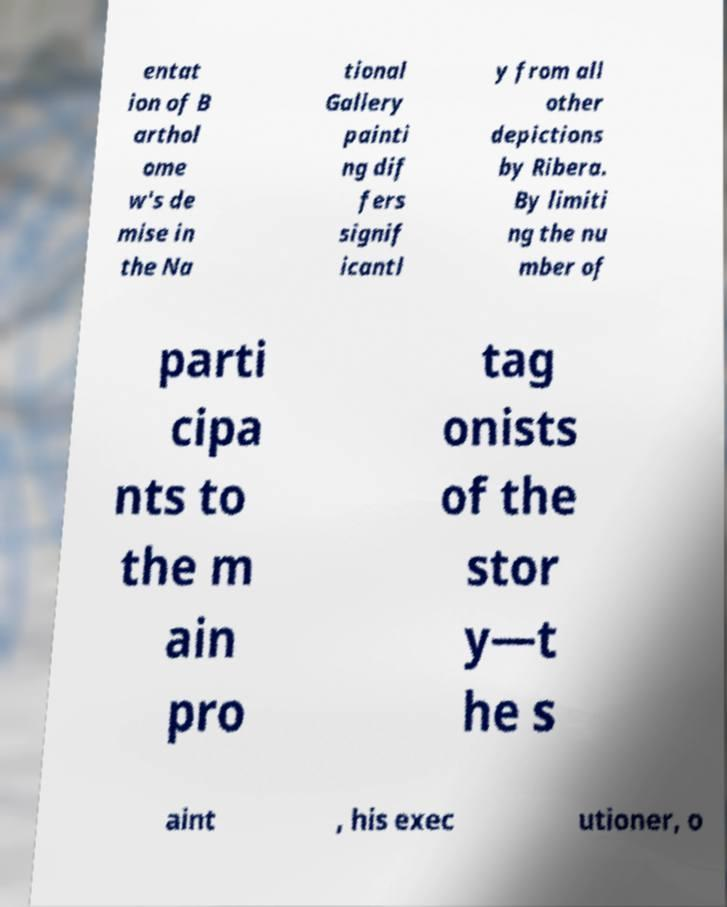What messages or text are displayed in this image? I need them in a readable, typed format. entat ion of B arthol ome w's de mise in the Na tional Gallery painti ng dif fers signif icantl y from all other depictions by Ribera. By limiti ng the nu mber of parti cipa nts to the m ain pro tag onists of the stor y—t he s aint , his exec utioner, o 